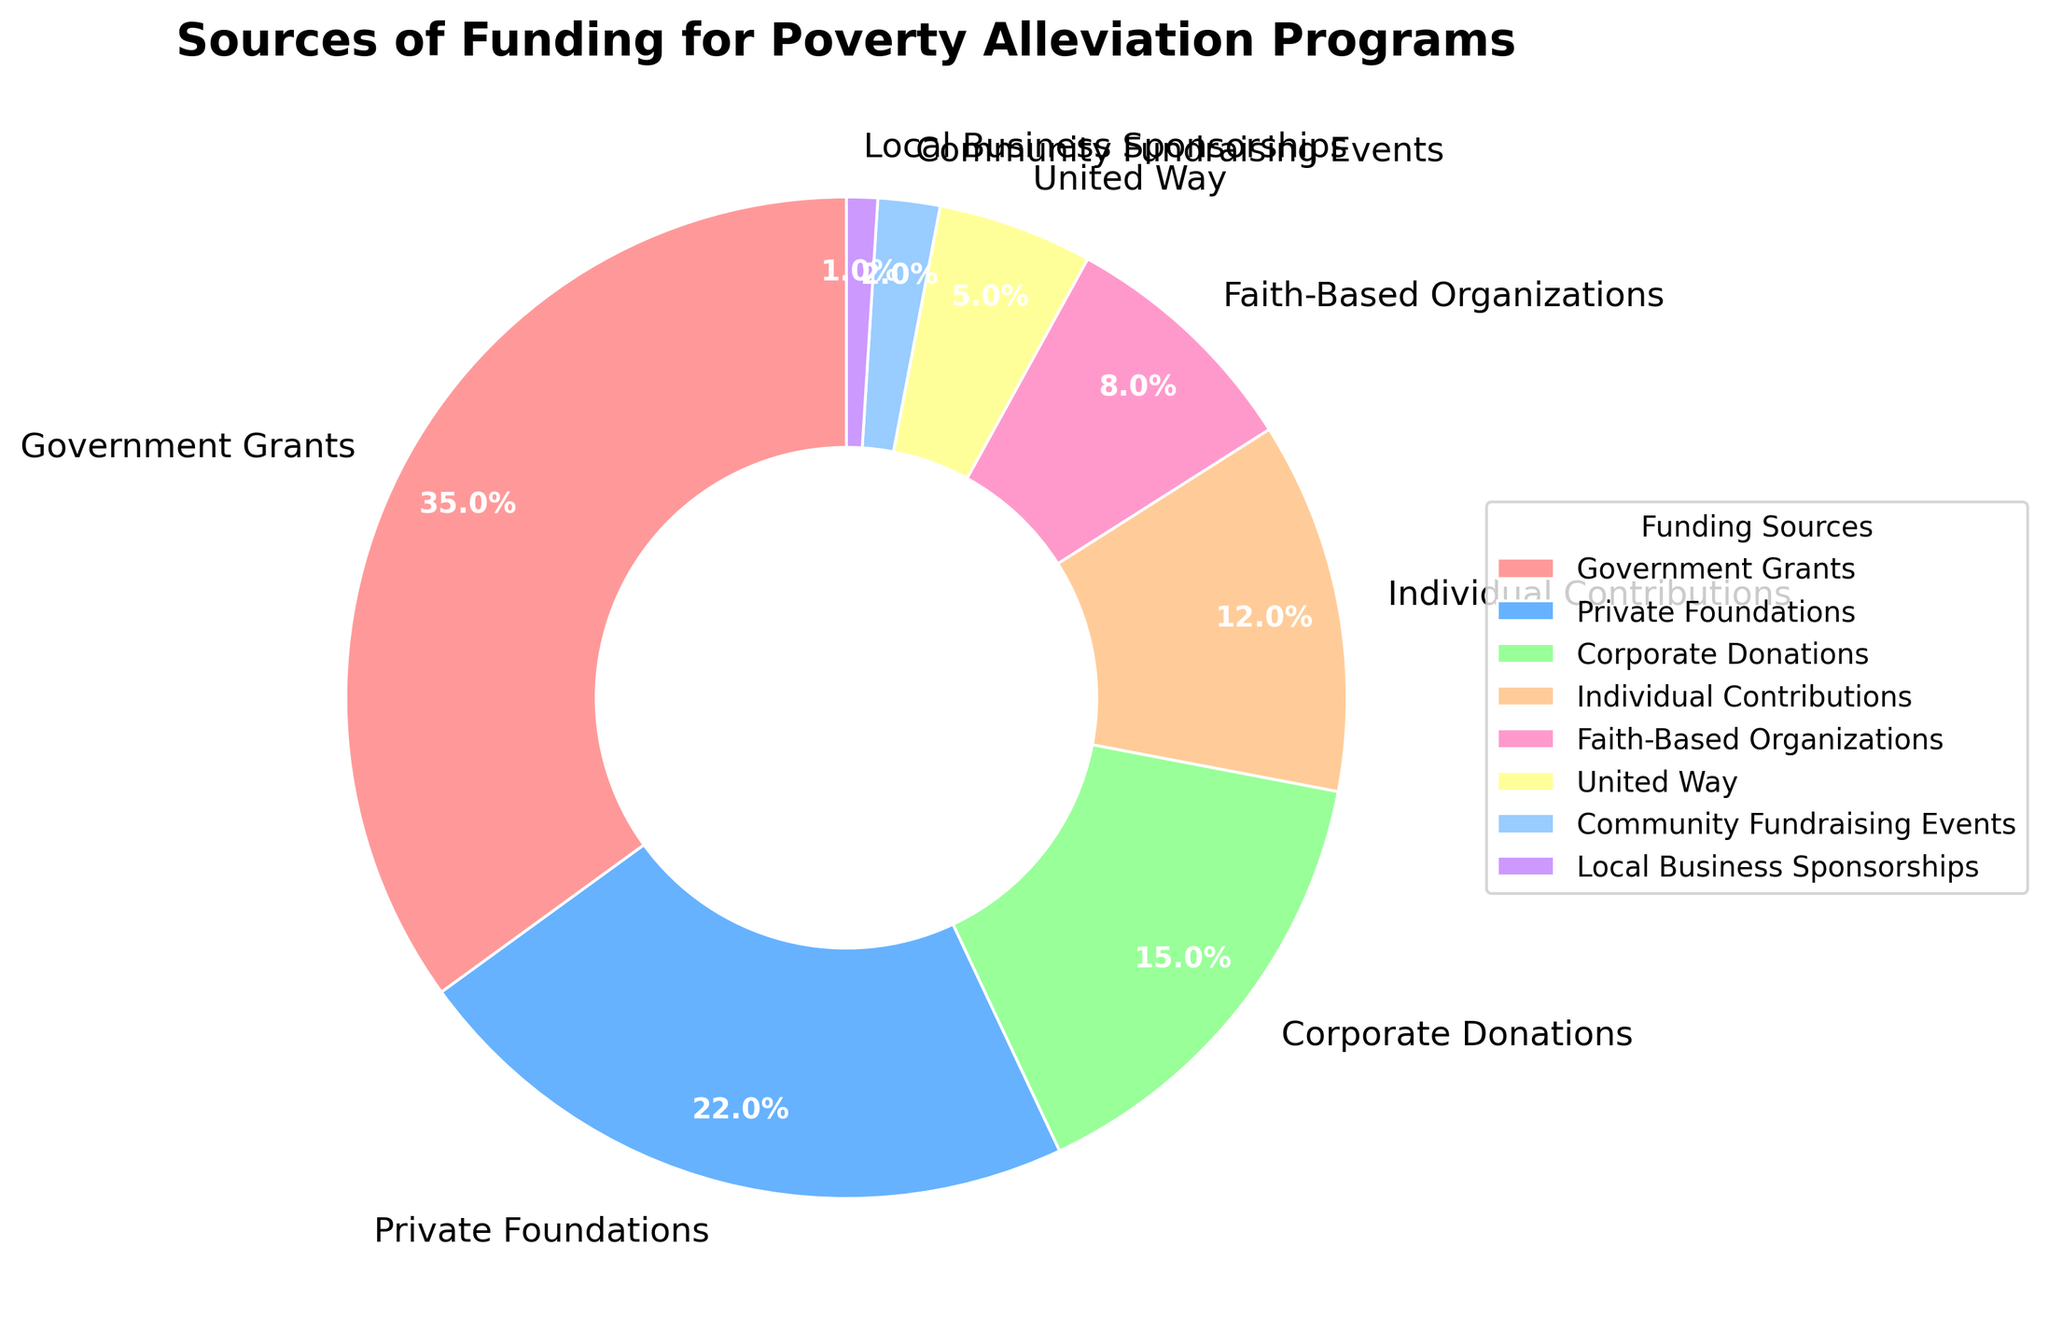Which funding source has the largest percentage? The pie chart shows that the largest segment is labeled "Government Grants" with a percentage of 35%.
Answer: Government Grants Compare the percentage of Corporate Donations to Individual Contributions. Which is higher? The pie chart lists Corporate Donations at 15% and Individual Contributions at 12%. 15% is higher than 12%.
Answer: Corporate Donations What is the combined percentage of Private Foundations and Faith-Based Organizations? The percentage for Private Foundations is 22% and for Faith-Based Organizations is 8%. Adding them together: 22% + 8% = 30%.
Answer: 30% How much greater is the percentage of Government Grants compared to United Way? Government Grants have a percentage of 35%, while United Way has a percentage of 5%. Subtracting these: 35% - 5% = 30%.
Answer: 30% Which funding sources each make up less than 10% of the total? By examining the pie chart, Faith-Based Organizations (8%), United Way (5%), Community Fundraising Events (2%), and Local Business Sponsorships (1%) each have less than 10%.
Answer: Faith-Based Organizations, United Way, Community Fundraising Events, Local Business Sponsorships If you combine the percentages of Individual Contributions, Community Fundraising Events, and Local Business Sponsorships, what is the total? The percentages are: Individual Contributions (12%), Community Fundraising Events (2%), and Local Business Sponsorships (1%). Adding them together: 12% + 2% + 1% = 15%.
Answer: 15% What percentage of the funding comes from individual sources (Private Foundations, Individual Contributions, Local Business Sponsorships)? Adding the percentages: Private Foundations (22%), Individual Contributions (12%), and Local Business Sponsorships (1%) = 22% + 12% + 1% = 35%.
Answer: 35% What percentage is represented by the smallest segment? The smallest segment is Local Business Sponsorships, which is labeled as 1%.
Answer: 1% Which color represents United Way? The pie chart shows United Way in a certain color, which is a shade (most likely yellow based on the usual color scheme suggested).
Answer: Yellow What is the total percentage represented by Corporate Donations, Faith-Based Organizations, and Community Fundraising Events? The percentages of Corporate Donations (15%), Faith-Based Organizations (8%), and Community Fundraising Events (2%) added together: 15% + 8% + 2% = 25%.
Answer: 25% 